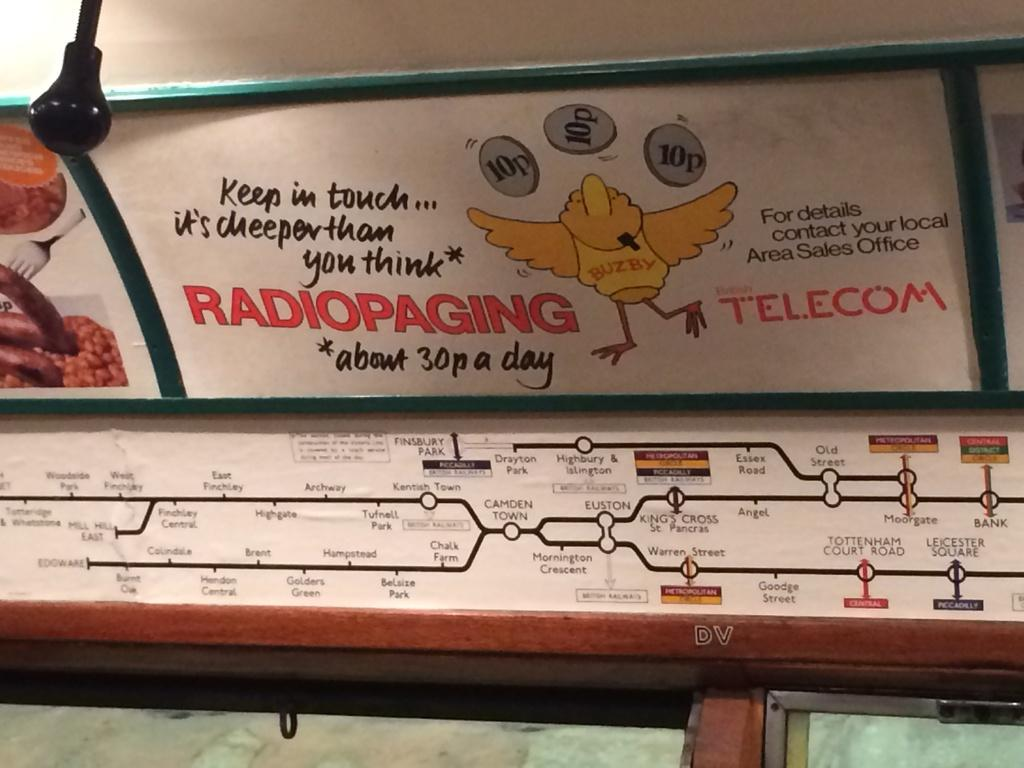<image>
Offer a succinct explanation of the picture presented. Ad on a train that has a chicken and is from Telecom. 